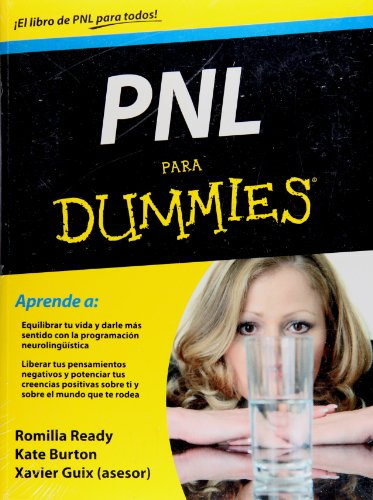Is this a motivational book? Absolutely, this book is designed to be motivational, offering strategies and insights into neurolinguistic programming to inspire personal transformation. 